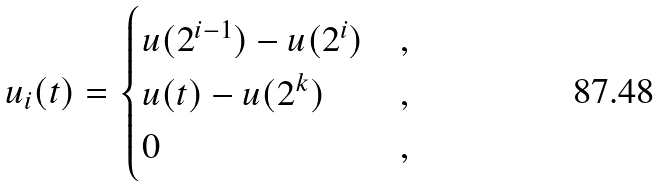<formula> <loc_0><loc_0><loc_500><loc_500>u _ { i } ( t ) = \begin{cases} u ( 2 ^ { i - 1 } ) - u ( 2 ^ { i } ) & , \\ u ( t ) - u ( 2 ^ { k } ) & , \\ 0 & , \end{cases}</formula> 